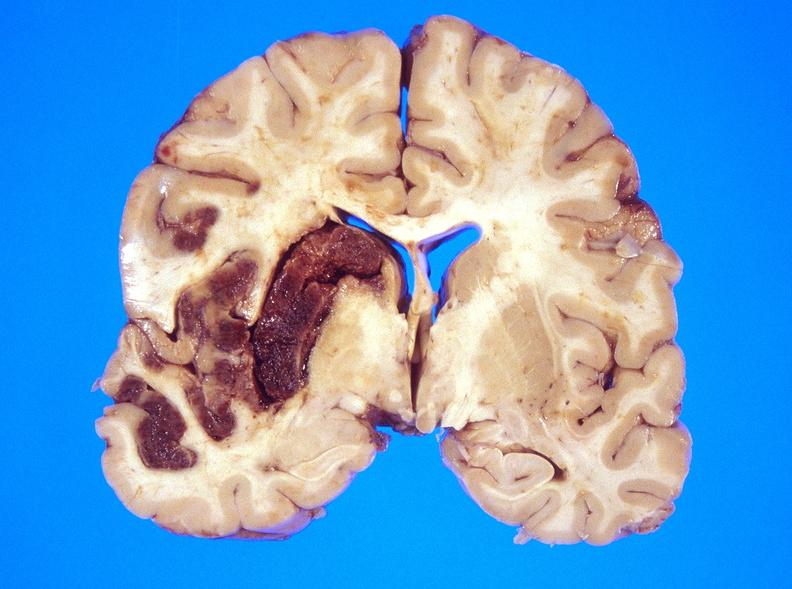what is present?
Answer the question using a single word or phrase. Nervous 